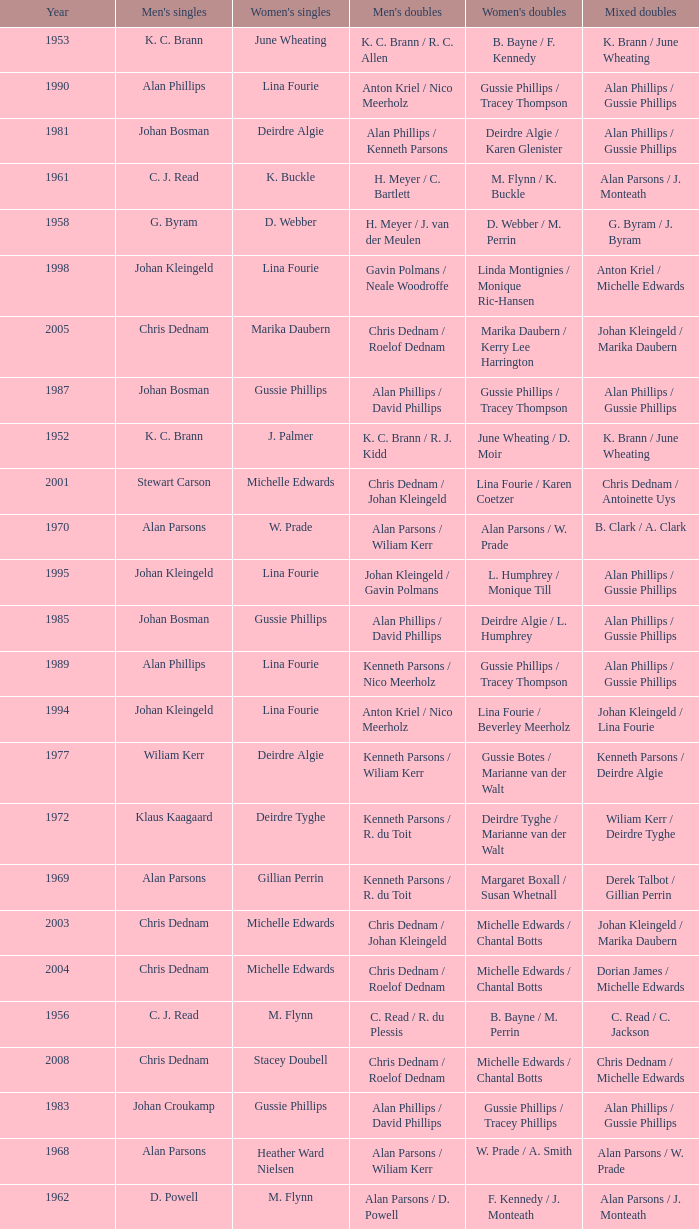Can you parse all the data within this table? {'header': ['Year', "Men's singles", "Women's singles", "Men's doubles", "Women's doubles", 'Mixed doubles'], 'rows': [['1953', 'K. C. Brann', 'June Wheating', 'K. C. Brann / R. C. Allen', 'B. Bayne / F. Kennedy', 'K. Brann / June Wheating'], ['1990', 'Alan Phillips', 'Lina Fourie', 'Anton Kriel / Nico Meerholz', 'Gussie Phillips / Tracey Thompson', 'Alan Phillips / Gussie Phillips'], ['1981', 'Johan Bosman', 'Deirdre Algie', 'Alan Phillips / Kenneth Parsons', 'Deirdre Algie / Karen Glenister', 'Alan Phillips / Gussie Phillips'], ['1961', 'C. J. Read', 'K. Buckle', 'H. Meyer / C. Bartlett', 'M. Flynn / K. Buckle', 'Alan Parsons / J. Monteath'], ['1958', 'G. Byram', 'D. Webber', 'H. Meyer / J. van der Meulen', 'D. Webber / M. Perrin', 'G. Byram / J. Byram'], ['1998', 'Johan Kleingeld', 'Lina Fourie', 'Gavin Polmans / Neale Woodroffe', 'Linda Montignies / Monique Ric-Hansen', 'Anton Kriel / Michelle Edwards'], ['2005', 'Chris Dednam', 'Marika Daubern', 'Chris Dednam / Roelof Dednam', 'Marika Daubern / Kerry Lee Harrington', 'Johan Kleingeld / Marika Daubern'], ['1987', 'Johan Bosman', 'Gussie Phillips', 'Alan Phillips / David Phillips', 'Gussie Phillips / Tracey Thompson', 'Alan Phillips / Gussie Phillips'], ['1952', 'K. C. Brann', 'J. Palmer', 'K. C. Brann / R. J. Kidd', 'June Wheating / D. Moir', 'K. Brann / June Wheating'], ['2001', 'Stewart Carson', 'Michelle Edwards', 'Chris Dednam / Johan Kleingeld', 'Lina Fourie / Karen Coetzer', 'Chris Dednam / Antoinette Uys'], ['1970', 'Alan Parsons', 'W. Prade', 'Alan Parsons / Wiliam Kerr', 'Alan Parsons / W. Prade', 'B. Clark / A. Clark'], ['1995', 'Johan Kleingeld', 'Lina Fourie', 'Johan Kleingeld / Gavin Polmans', 'L. Humphrey / Monique Till', 'Alan Phillips / Gussie Phillips'], ['1985', 'Johan Bosman', 'Gussie Phillips', 'Alan Phillips / David Phillips', 'Deirdre Algie / L. Humphrey', 'Alan Phillips / Gussie Phillips'], ['1989', 'Alan Phillips', 'Lina Fourie', 'Kenneth Parsons / Nico Meerholz', 'Gussie Phillips / Tracey Thompson', 'Alan Phillips / Gussie Phillips'], ['1994', 'Johan Kleingeld', 'Lina Fourie', 'Anton Kriel / Nico Meerholz', 'Lina Fourie / Beverley Meerholz', 'Johan Kleingeld / Lina Fourie'], ['1977', 'Wiliam Kerr', 'Deirdre Algie', 'Kenneth Parsons / Wiliam Kerr', 'Gussie Botes / Marianne van der Walt', 'Kenneth Parsons / Deirdre Algie'], ['1972', 'Klaus Kaagaard', 'Deirdre Tyghe', 'Kenneth Parsons / R. du Toit', 'Deirdre Tyghe / Marianne van der Walt', 'Wiliam Kerr / Deirdre Tyghe'], ['1969', 'Alan Parsons', 'Gillian Perrin', 'Kenneth Parsons / R. du Toit', 'Margaret Boxall / Susan Whetnall', 'Derek Talbot / Gillian Perrin'], ['2003', 'Chris Dednam', 'Michelle Edwards', 'Chris Dednam / Johan Kleingeld', 'Michelle Edwards / Chantal Botts', 'Johan Kleingeld / Marika Daubern'], ['2004', 'Chris Dednam', 'Michelle Edwards', 'Chris Dednam / Roelof Dednam', 'Michelle Edwards / Chantal Botts', 'Dorian James / Michelle Edwards'], ['1956', 'C. J. Read', 'M. Flynn', 'C. Read / R. du Plessis', 'B. Bayne / M. Perrin', 'C. Read / C. Jackson'], ['2008', 'Chris Dednam', 'Stacey Doubell', 'Chris Dednam / Roelof Dednam', 'Michelle Edwards / Chantal Botts', 'Chris Dednam / Michelle Edwards'], ['1983', 'Johan Croukamp', 'Gussie Phillips', 'Alan Phillips / David Phillips', 'Gussie Phillips / Tracey Phillips', 'Alan Phillips / Gussie Phillips'], ['1968', 'Alan Parsons', 'Heather Ward Nielsen', 'Alan Parsons / Wiliam Kerr', 'W. Prade / A. Smith', 'Alan Parsons / W. Prade'], ['1962', 'D. Powell', 'M. Flynn', 'Alan Parsons / D. Powell', 'F. Kennedy / J. Monteath', 'Alan Parsons / J. Monteath'], ['2000', 'Michael Adams', 'Michelle Edwards', 'Nico Meerholz / Anton Kriel', 'Lina Fourie / Karen Coetzer', 'Anton Kriel / Michelle Edwards'], ['1982', 'Alan Phillips', 'Gussie Phillips', 'Alan Phillips / Kenneth Parsons', 'Gussie Phillips / Tracey Phillips', 'Alan Phillips / Gussie Phillips'], ['1965', 'Alan Parsons', 'Ursula Smith', 'Alan Parsons / Wiliam Kerr', 'Ursula Smith / Jennifer Pritchard', 'Alan Parsons / W. Prade'], ['1974', 'Wiliam Kerr', 'Deirdre Tyghe', 'Alan Parsons / Wiliam Kerr', 'Joke van Beusekom / Marjan Luesken', 'Wiliam Kerr / Deirdre Tyghe'], ['2007', 'Wiaan Viljoen', 'Stacey Doubell', 'Chris Dednam / Roelof Dednam', 'Michelle Edwards / Chantal Botts', 'Dorian James / Michelle Edwards'], ['1959', 'Alan Parsons', 'Heather Ward', 'H. Meyer / D. Powell', 'Heather Ward / Barbara Carpenter', 'D. Powell / K. Buckle'], ['1963', 'C. Bartlett', 'J. Byram', 'P. Griffin / C. Bartlett', 'S. Bartlett / J. Greener', 'C. Bartlett / K. Stravidis'], ['1950', 'K. C. Brann', 'F. Mckenzie', 'K. C. Brann / R. C. Allen', 'B. Bayne / F. Mckenzie', 'K. Brann / F. Mckenzie'], ['1971', 'Alan Parsons', 'Pam Stockton', 'Donald C. Paup / Chris Kinard', 'Pam Stockton / Caroline Hein', 'Alan Parsons / W. Prade'], ['1999', 'Michael Adams', 'Lina Fourie', 'Johan Kleingeld / Anton Kriel', 'Linda Montignies / Monique Ric-Hansen', 'Johan Kleingeld / Karen Coetzer'], ['1948', 'Noel B. Radford', 'Betty Uber', 'R. C. Allen / E. S. Irwin', 'Betty Uber / Queenie Allen', 'Noel B. Radford / Betty Uber'], ['1997', 'Johan Kleingeld', 'Lina Fourie', 'Warren Parsons / Neale Woodroffe', 'Lina Fourie / Tracey Thompson', 'Johan Kleingeld / Lina Fourie'], ['2009', 'Roelof Dednam', 'Kerry Lee Harrington', 'Dorian James / Wiaan Viljoen', 'Michelle Edwards / Annari Viljoen', 'Chris Dednam / Annari Viljoen'], ['1975', 'Paul Whetnall', 'Deirdre Tyghe', 'Paul Whetnall / Ray Stevens', 'Sue Whetnall / Barbara Giles', 'Paul Whetnall / Susan Whetnall'], ['1979', 'Johan Croukamp', 'Gussie Botes', 'Gordon McMillan / John Abrahams', 'Gussie Botes / Marianne Abrahams', 'Alan Phillips / Gussie Botes'], ['1986', 'Johan Bosman', 'Vanessa van der Walt', 'Alan Phillips / David Phillips', 'Gussie Phillips / Tracey Thompson', 'Alan Phillips / Gussie Phillips'], ['1996', 'Warren Parsons', 'Lina Fourie', 'Johan Kleingeld / Gavin Polmans', 'Linda Montignies / Monique Till', 'Anton Kriel / Vanessa van der Walt'], ['2002', 'Stewart Carson', 'Michelle Edwards', 'Chris Dednam / Johan Kleingeld', 'Michelle Edwards / Chantal Botts', 'Johan Kleingeld / Marika Daubern'], ['1960', 'C. Bartlett', 'M. Flynn', 'C. Read / D. Powell', 'M. Flynn / K. Buckle', 'D. Powell / K. Buckle'], ['1993', 'Johan Kleingeld', 'Lina Fourie', 'Anton Kriel / Nico Meerholz', 'Gussie Phillips / Tracey Thompson', 'Johan Kleingeld / Lina Fourie'], ['1978', 'Gordon McMillan', 'Deirdre Algie', 'Gordon McMillan / John Abrahams', 'Gussie Botes / Marianne Abrahams', 'Kenneth Parsons / Deirdre Algie'], ['1964', 'Alan Parsons', 'W. Prade', 'Alan Parsons / Wiliam Kerr', 'M. Harris / L. Marshall', 'Wiliam Kerr / J. Monteath'], ['2006', 'Chris Dednam', 'Kerry Lee Harrington', 'Chris Dednam / Roelof Dednam', 'Michelle Edwards / Chantal Botts', 'Dorian James / Michelle Edwards'], ['1988', 'Alan Phillips', 'Gussie Phillips', 'Alan Phillips / David Phillips', 'Gussie Phillips / Tracey Thompson', 'Alan Phillips / Gussie Phillips'], ['1991', 'Anton Kriel', 'Lina Fourie', 'Anton Kriel / Nico Meerholz', 'Lina Fourie / E. Fourie', 'Anton Kriel / Vanessa van der Walt'], ['1957', 'G. Byram', 'D. Webber', 'G. Byram / D. Anderson', 'D. Webber / M. Perrin', 'G. Byram / J. Byram'], ['1966', 'Alan Parsons', 'W. Prade', 'Alan Parsons / Wiliam Kerr', 'W. Prade / A. Smith', 'Alan Parsons / W. Prade'], ['1976', 'Ray Stevens', 'Margaret Lockwood', 'Mike Tredgett / Ray Stevens', 'Nora Gardner / Margaret Lockwood', 'Mike Tredgett / Nora Gardner'], ['1984', 'Johan Croukamp', 'Karen Glenister', 'Alan Phillips / David Phillips', 'Gussie Phillips / Tracey Phillips', 'Alan Phillips / Gussie Phillips'], ['1980', 'Chris Kinard', 'Utami Kinard', 'Alan Phillips / Kenneth Parsons', 'Gussie Phillips / Marianne Abrahams', 'Alan Phillips / Gussie Phillips'], ['1955', 'C. J. Read', 'B. Mare', 'B. Brownlee / D. Anderson', 'B. Bayne / F. Kennedy', 'C. Read / B. Mare'], ['1967', 'Alan Parsons', 'Irmgard Latz', 'Alan Parsons / Wiliam Kerr', 'Marieluise Wackerow / Irmgard Latz', 'W. Lightbody / H. Boltman'], ['1992', 'D. Plasson', 'Lina Fourie', 'Anton Kriel / Nico Meerholz', 'Gussie Phillips / Tracey Thompson', 'Anton Kriel / Vanessa van der Walt'], ['1973', 'Wiliam Kerr', 'Deirdre Tyghe', 'Alan Parsons / Wiliam Kerr', 'Deirdre Tyghe / Marianne van der Walt', 'Wiliam Kerr / Deirdre Tyghe']]} Which Men's doubles have a Year smaller than 1960, and Men's singles of noel b. radford? R. C. Allen / E. S. Irwin. 